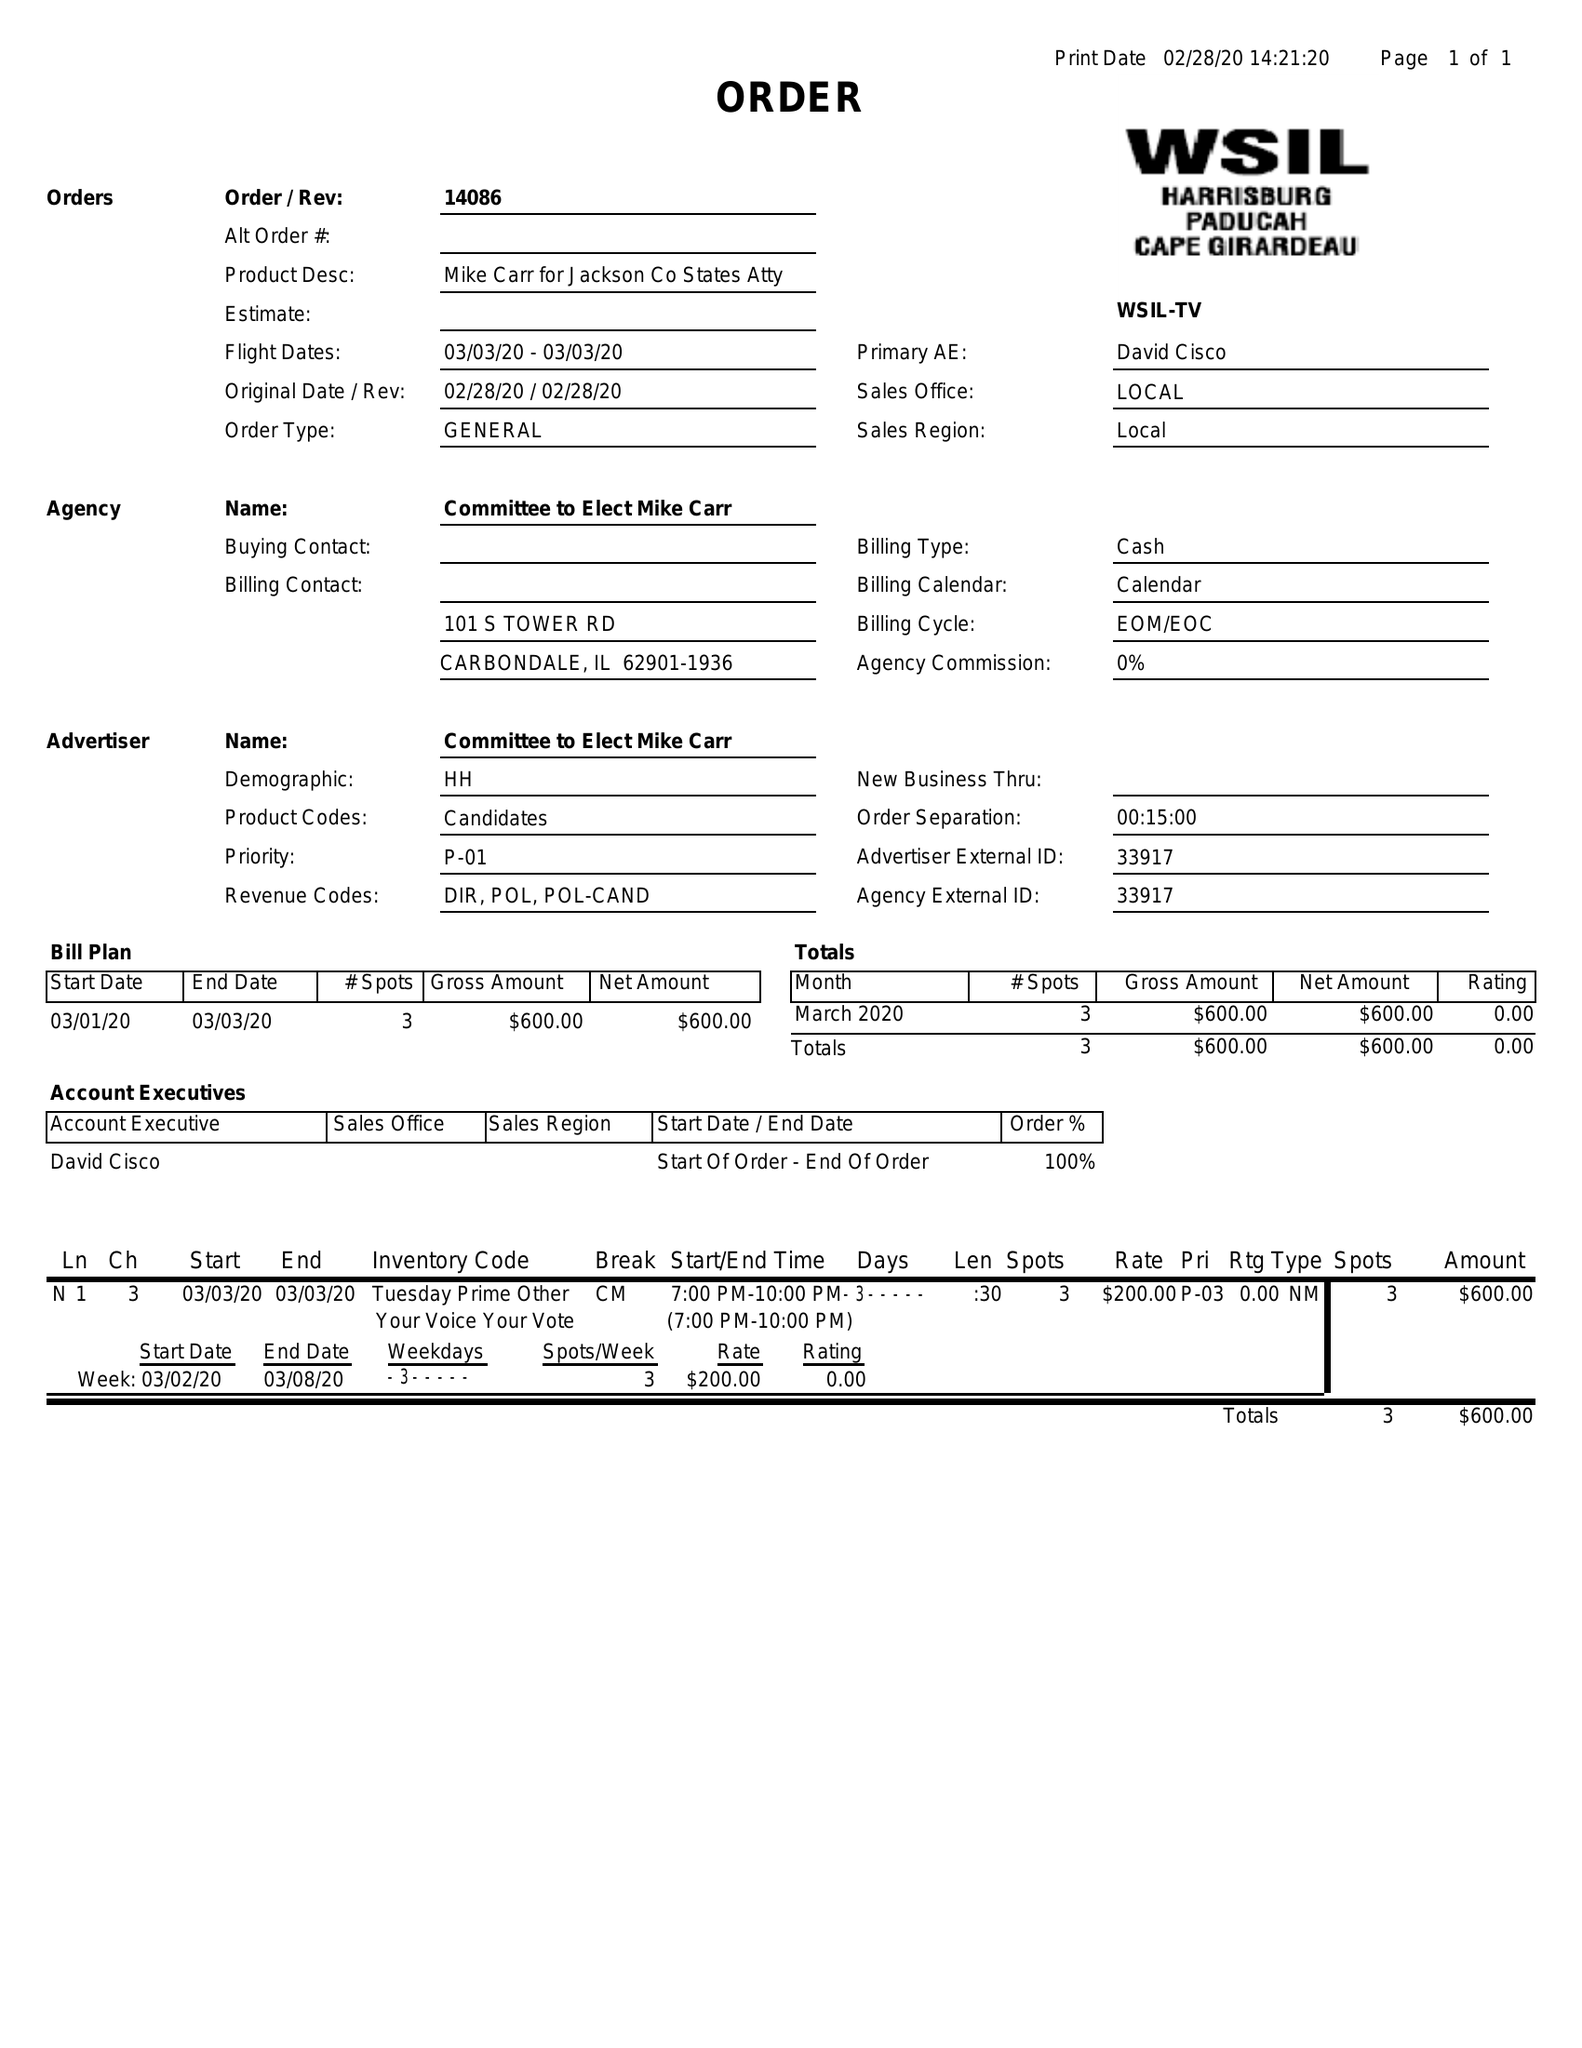What is the value for the flight_to?
Answer the question using a single word or phrase. 03/03/20 